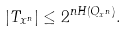Convert formula to latex. <formula><loc_0><loc_0><loc_500><loc_500>| T _ { x ^ { n } } | \leq 2 ^ { n H ( Q _ { x ^ { n } } ) } .</formula> 